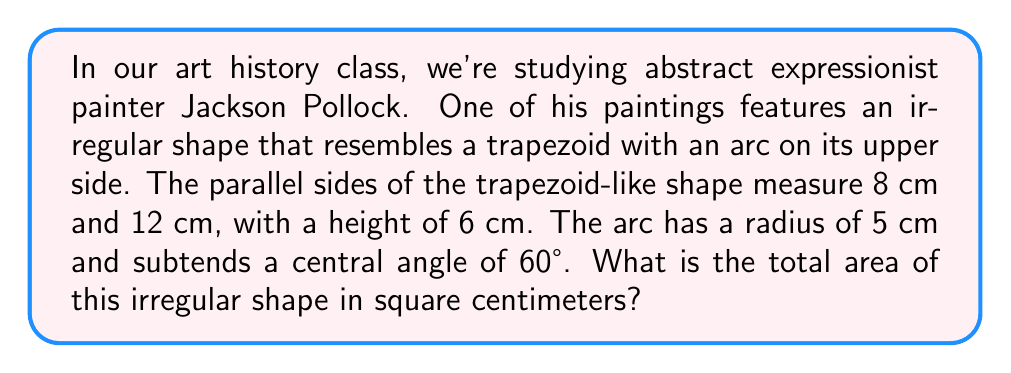Help me with this question. Let's break this down step-by-step:

1) First, we'll calculate the area of the trapezoid:
   Area of trapezoid = $\frac{1}{2}(a+b)h$
   where $a$ and $b$ are the parallel sides and $h$ is the height.
   $$A_{trapezoid} = \frac{1}{2}(8+12) \cdot 6 = 60 \text{ cm}^2$$

2) Now, we need to calculate the area of the circular sector:
   Area of sector = $\frac{\theta}{360°} \pi r^2$
   where $\theta$ is the central angle in degrees and $r$ is the radius.
   $$A_{sector} = \frac{60}{360} \pi \cdot 5^2 = \frac{25\pi}{6} \text{ cm}^2$$

3) However, we need to subtract the area of the triangle formed by the sector:
   Area of triangle = $\frac{1}{2}r^2 \sin \theta$
   $$A_{triangle} = \frac{1}{2} \cdot 5^2 \cdot \sin 60° = \frac{25\sqrt{3}}{4} \text{ cm}^2$$

4) The area of the arc segment is:
   $$A_{arc} = A_{sector} - A_{triangle} = \frac{25\pi}{6} - \frac{25\sqrt{3}}{4} \text{ cm}^2$$

5) The total area of the irregular shape is:
   $$A_{total} = A_{trapezoid} + A_{arc} = 60 + \frac{25\pi}{6} - \frac{25\sqrt{3}}{4} \text{ cm}^2$$

[asy]
unitsize(1cm);
path p = (0,0)--(12,0)--(10,6)--(2,6)--cycle;
path q = arc((6,6),5,180,240);
draw(p);
draw(q);
label("12 cm", (6,0), S);
label("8 cm", (6,6), N);
label("6 cm", (0,3), W);
label("r = 5 cm", (8,6), NE);
label("60°", (6,6), SE);
[/asy]
Answer: $60 + \frac{25\pi}{6} - \frac{25\sqrt{3}}{4} \text{ cm}^2$ 